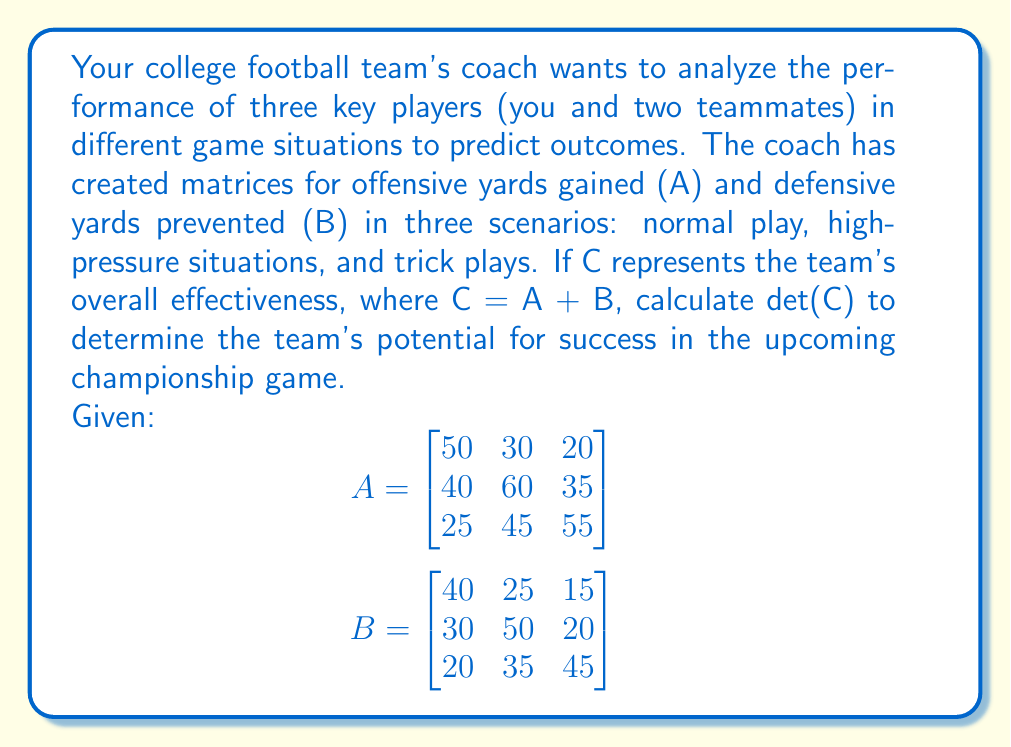Show me your answer to this math problem. Let's approach this step-by-step:

1) First, we need to calculate matrix C by adding A and B:

   $$C = A + B = \begin{bmatrix}
   50+40 & 30+25 & 20+15 \\
   40+30 & 60+50 & 35+20 \\
   25+20 & 45+35 & 55+45
   \end{bmatrix}$$

2) This gives us:

   $$C = \begin{bmatrix}
   90 & 55 & 35 \\
   70 & 110 & 55 \\
   45 & 80 & 100
   \end{bmatrix}$$

3) Now, we need to calculate det(C). For a 3x3 matrix, we can use the following formula:

   $$det(C) = a(ei-fh) - b(di-fg) + c(dh-eg)$$

   where $a$, $b$, $c$ are the elements of the first row, and:
   $$\begin{bmatrix}
   a & b & c \\
   d & e & f \\
   g & h & i
   \end{bmatrix}$$

4) Substituting our values:

   $$det(C) = 90[(110)(100) - (55)(80)] - 55[(70)(100) - (55)(45)] + 35[(70)(80) - (110)(45)]$$

5) Let's calculate each part:
   
   $90(11000 - 4400) = 90(6600) = 594000$
   $55(7000 - 2475) = 55(4525) = 248875$
   $35(5600 - 4950) = 35(650) = 22750$

6) Now, we sum these up:

   $det(C) = 594000 - 248875 + 22750 = 367875$
Answer: 367875 